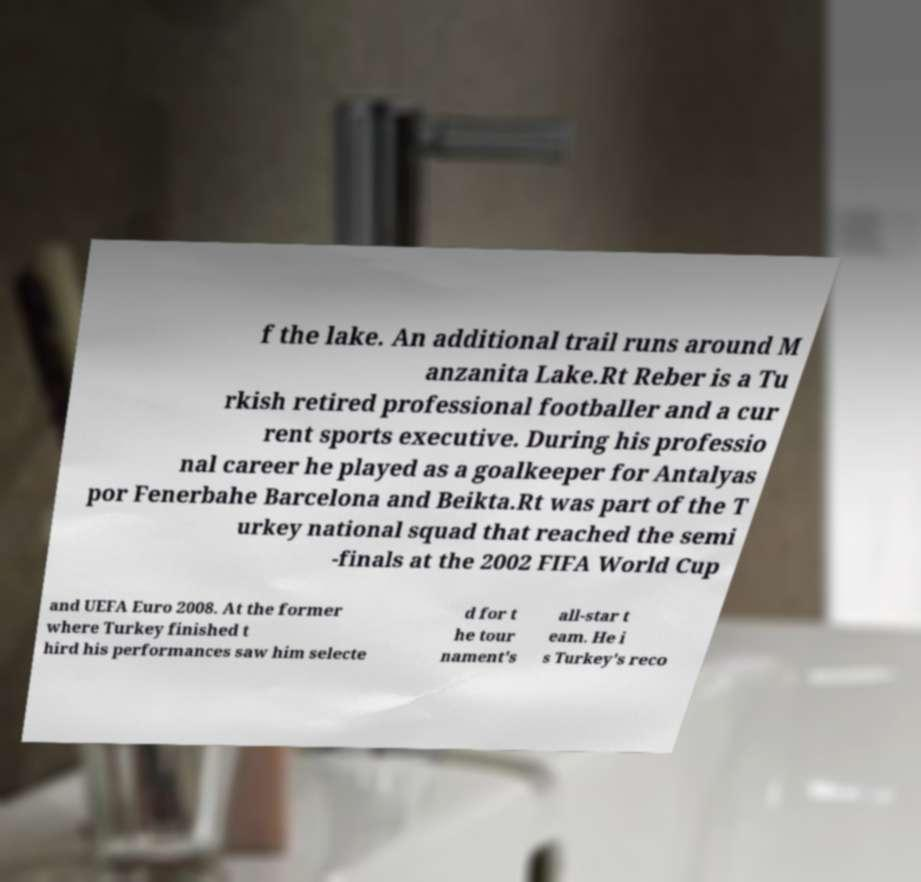Can you read and provide the text displayed in the image?This photo seems to have some interesting text. Can you extract and type it out for me? f the lake. An additional trail runs around M anzanita Lake.Rt Reber is a Tu rkish retired professional footballer and a cur rent sports executive. During his professio nal career he played as a goalkeeper for Antalyas por Fenerbahe Barcelona and Beikta.Rt was part of the T urkey national squad that reached the semi -finals at the 2002 FIFA World Cup and UEFA Euro 2008. At the former where Turkey finished t hird his performances saw him selecte d for t he tour nament's all-star t eam. He i s Turkey's reco 